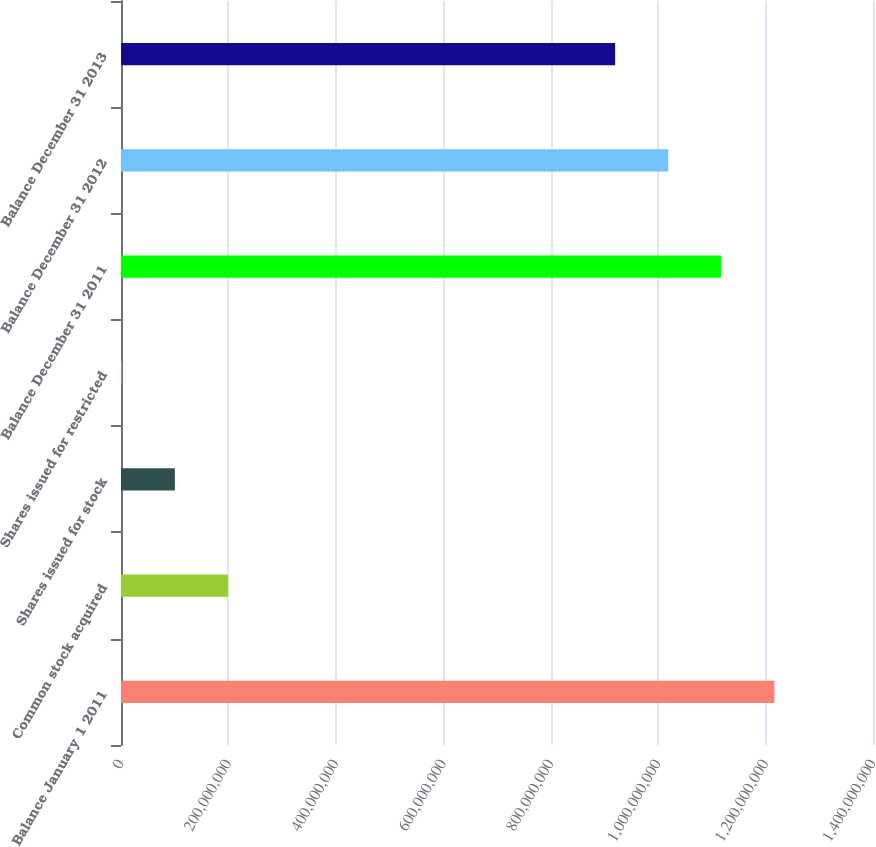Convert chart. <chart><loc_0><loc_0><loc_500><loc_500><bar_chart><fcel>Balance January 1 2011<fcel>Common stock acquired<fcel>Shares issued for stock<fcel>Shares issued for restricted<fcel>Balance December 31 2011<fcel>Balance December 31 2012<fcel>Balance December 31 2013<nl><fcel>1.21642e+09<fcel>1.99108e+08<fcel>1.00283e+08<fcel>1.45933e+06<fcel>1.11759e+09<fcel>1.01877e+09<fcel>9.19947e+08<nl></chart> 